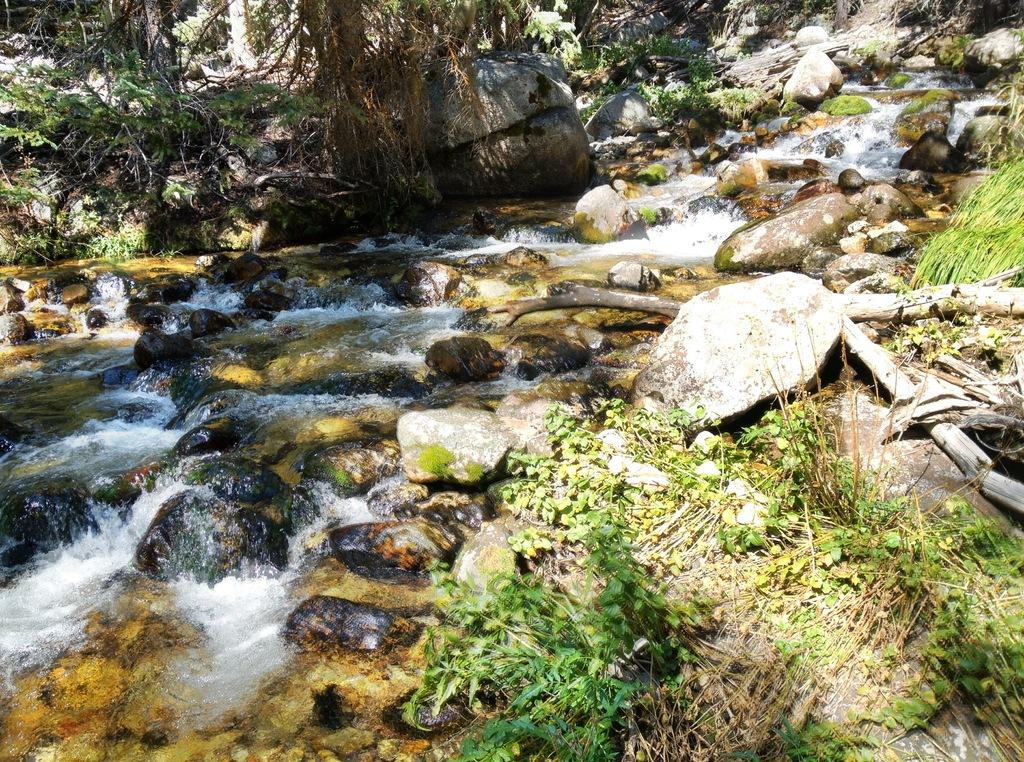What is the primary element visible in the image? There is water in the image. What other objects can be seen in the image? There are stones in the image. What can be seen in the background of the image? There are trees in the background of the image. What color are the trees in the image? The trees are green in color. How does the fork help the earth in the image? There is no fork present in the image, so it cannot help the earth. 